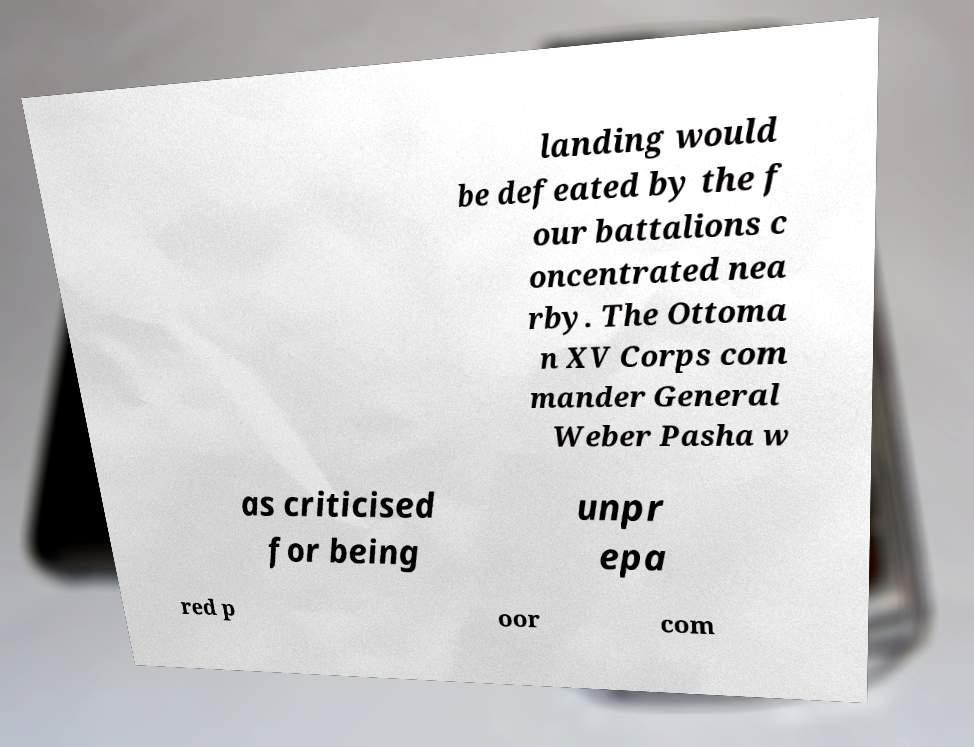I need the written content from this picture converted into text. Can you do that? landing would be defeated by the f our battalions c oncentrated nea rby. The Ottoma n XV Corps com mander General Weber Pasha w as criticised for being unpr epa red p oor com 